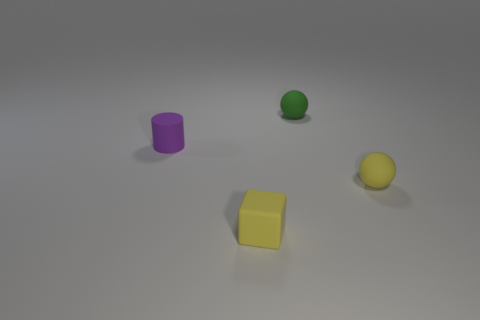Add 4 blocks. How many objects exist? 8 Subtract all cylinders. How many objects are left? 3 Add 1 purple matte objects. How many purple matte objects are left? 2 Add 1 small cylinders. How many small cylinders exist? 2 Subtract 0 brown blocks. How many objects are left? 4 Subtract all yellow blocks. Subtract all blue cubes. How many objects are left? 3 